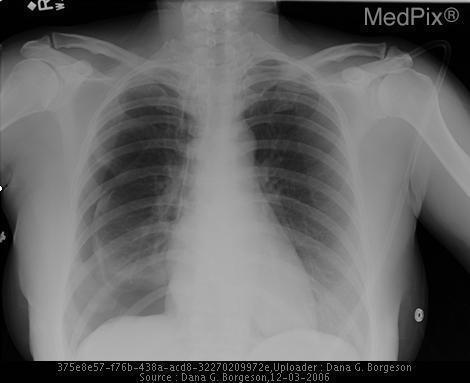Does this patient have a pneumothorax?
Concise answer only. Yes. Does this patient have a pleural effusion?
Give a very brief answer. No. Which side is the pneumothorax on?
Write a very short answer. Right side. 